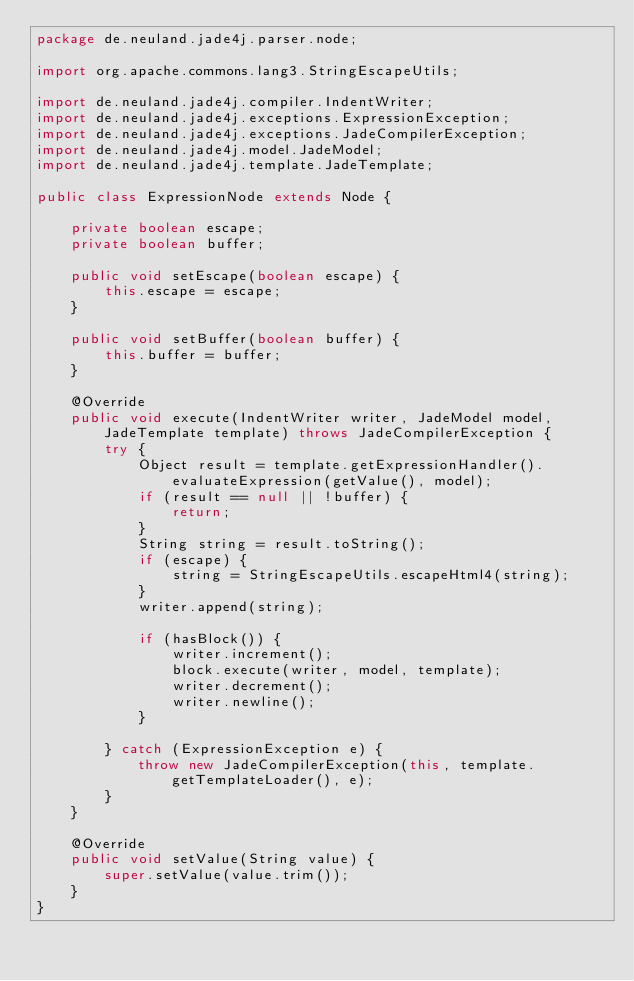<code> <loc_0><loc_0><loc_500><loc_500><_Java_>package de.neuland.jade4j.parser.node;

import org.apache.commons.lang3.StringEscapeUtils;

import de.neuland.jade4j.compiler.IndentWriter;
import de.neuland.jade4j.exceptions.ExpressionException;
import de.neuland.jade4j.exceptions.JadeCompilerException;
import de.neuland.jade4j.model.JadeModel;
import de.neuland.jade4j.template.JadeTemplate;

public class ExpressionNode extends Node {

	private boolean escape;
	private boolean buffer;

	public void setEscape(boolean escape) {
		this.escape = escape;
	}

	public void setBuffer(boolean buffer) {
		this.buffer = buffer;
	}

	@Override
	public void execute(IndentWriter writer, JadeModel model, JadeTemplate template) throws JadeCompilerException {
		try {
			Object result = template.getExpressionHandler().evaluateExpression(getValue(), model);
			if (result == null || !buffer) {
				return;
			}
			String string = result.toString();
			if (escape) {
				string = StringEscapeUtils.escapeHtml4(string);
			}
			writer.append(string);

            if (hasBlock()) {
                writer.increment();
                block.execute(writer, model, template);
                writer.decrement();
                writer.newline();
            }

		} catch (ExpressionException e) {
			throw new JadeCompilerException(this, template.getTemplateLoader(), e);
		}
	}

	@Override
	public void setValue(String value) {
		super.setValue(value.trim());
	}
}
</code> 